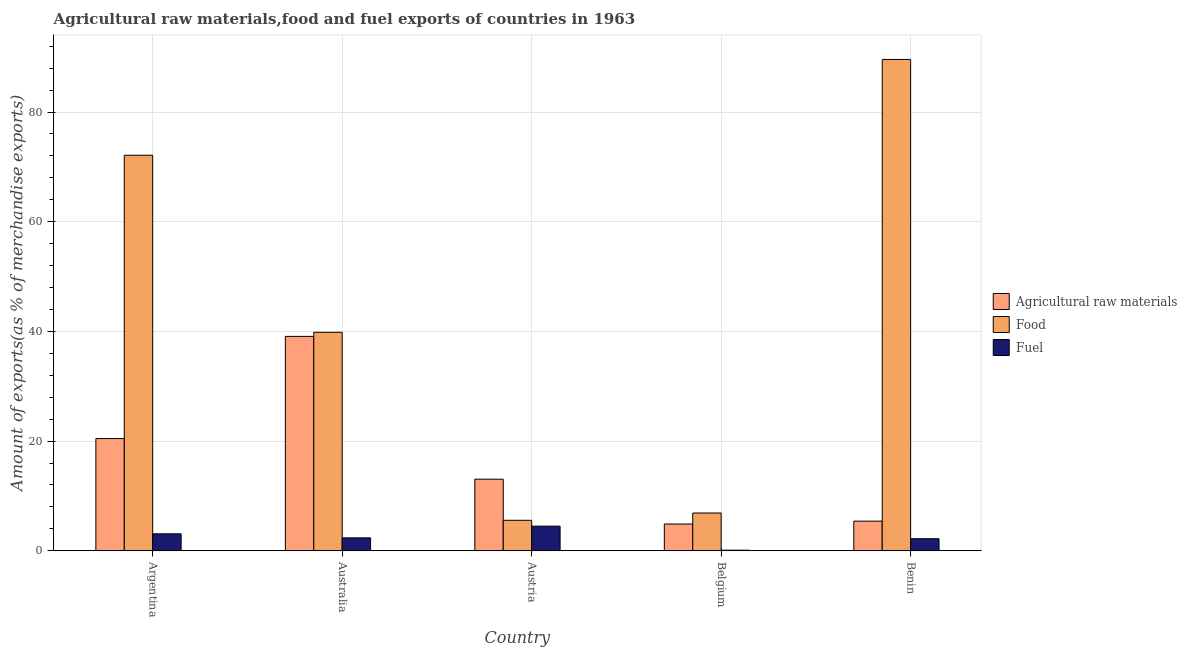How many groups of bars are there?
Your answer should be compact. 5. Are the number of bars per tick equal to the number of legend labels?
Offer a terse response. Yes. Are the number of bars on each tick of the X-axis equal?
Provide a short and direct response. Yes. What is the percentage of food exports in Australia?
Provide a succinct answer. 39.83. Across all countries, what is the maximum percentage of food exports?
Offer a very short reply. 89.59. Across all countries, what is the minimum percentage of fuel exports?
Offer a terse response. 0.11. In which country was the percentage of fuel exports maximum?
Ensure brevity in your answer.  Austria. What is the total percentage of fuel exports in the graph?
Offer a terse response. 12.24. What is the difference between the percentage of fuel exports in Argentina and that in Australia?
Give a very brief answer. 0.74. What is the difference between the percentage of raw materials exports in Benin and the percentage of fuel exports in Austria?
Your answer should be very brief. 0.91. What is the average percentage of food exports per country?
Keep it short and to the point. 42.8. What is the difference between the percentage of food exports and percentage of fuel exports in Argentina?
Make the answer very short. 69.03. In how many countries, is the percentage of fuel exports greater than 80 %?
Provide a short and direct response. 0. What is the ratio of the percentage of food exports in Australia to that in Belgium?
Your answer should be compact. 5.78. Is the percentage of food exports in Argentina less than that in Benin?
Offer a very short reply. Yes. Is the difference between the percentage of food exports in Argentina and Australia greater than the difference between the percentage of raw materials exports in Argentina and Australia?
Give a very brief answer. Yes. What is the difference between the highest and the second highest percentage of food exports?
Give a very brief answer. 17.46. What is the difference between the highest and the lowest percentage of raw materials exports?
Your answer should be very brief. 34.21. What does the 2nd bar from the left in Benin represents?
Make the answer very short. Food. What does the 3rd bar from the right in Benin represents?
Keep it short and to the point. Agricultural raw materials. How many bars are there?
Your response must be concise. 15. Does the graph contain any zero values?
Make the answer very short. No. Where does the legend appear in the graph?
Your answer should be compact. Center right. How are the legend labels stacked?
Your answer should be compact. Vertical. What is the title of the graph?
Provide a short and direct response. Agricultural raw materials,food and fuel exports of countries in 1963. What is the label or title of the Y-axis?
Keep it short and to the point. Amount of exports(as % of merchandise exports). What is the Amount of exports(as % of merchandise exports) of Agricultural raw materials in Argentina?
Your answer should be very brief. 20.46. What is the Amount of exports(as % of merchandise exports) of Food in Argentina?
Make the answer very short. 72.12. What is the Amount of exports(as % of merchandise exports) in Fuel in Argentina?
Make the answer very short. 3.09. What is the Amount of exports(as % of merchandise exports) of Agricultural raw materials in Australia?
Give a very brief answer. 39.09. What is the Amount of exports(as % of merchandise exports) of Food in Australia?
Keep it short and to the point. 39.83. What is the Amount of exports(as % of merchandise exports) of Fuel in Australia?
Make the answer very short. 2.35. What is the Amount of exports(as % of merchandise exports) of Agricultural raw materials in Austria?
Provide a short and direct response. 13.06. What is the Amount of exports(as % of merchandise exports) in Food in Austria?
Keep it short and to the point. 5.56. What is the Amount of exports(as % of merchandise exports) in Fuel in Austria?
Offer a terse response. 4.49. What is the Amount of exports(as % of merchandise exports) of Agricultural raw materials in Belgium?
Ensure brevity in your answer.  4.88. What is the Amount of exports(as % of merchandise exports) of Food in Belgium?
Provide a succinct answer. 6.89. What is the Amount of exports(as % of merchandise exports) in Fuel in Belgium?
Your answer should be very brief. 0.11. What is the Amount of exports(as % of merchandise exports) in Agricultural raw materials in Benin?
Your response must be concise. 5.4. What is the Amount of exports(as % of merchandise exports) of Food in Benin?
Give a very brief answer. 89.59. What is the Amount of exports(as % of merchandise exports) of Fuel in Benin?
Keep it short and to the point. 2.2. Across all countries, what is the maximum Amount of exports(as % of merchandise exports) of Agricultural raw materials?
Provide a succinct answer. 39.09. Across all countries, what is the maximum Amount of exports(as % of merchandise exports) of Food?
Make the answer very short. 89.59. Across all countries, what is the maximum Amount of exports(as % of merchandise exports) of Fuel?
Ensure brevity in your answer.  4.49. Across all countries, what is the minimum Amount of exports(as % of merchandise exports) in Agricultural raw materials?
Your answer should be compact. 4.88. Across all countries, what is the minimum Amount of exports(as % of merchandise exports) in Food?
Offer a very short reply. 5.56. Across all countries, what is the minimum Amount of exports(as % of merchandise exports) of Fuel?
Your answer should be compact. 0.11. What is the total Amount of exports(as % of merchandise exports) in Agricultural raw materials in the graph?
Your response must be concise. 82.88. What is the total Amount of exports(as % of merchandise exports) in Food in the graph?
Your answer should be compact. 214. What is the total Amount of exports(as % of merchandise exports) in Fuel in the graph?
Make the answer very short. 12.24. What is the difference between the Amount of exports(as % of merchandise exports) of Agricultural raw materials in Argentina and that in Australia?
Your answer should be very brief. -18.63. What is the difference between the Amount of exports(as % of merchandise exports) in Food in Argentina and that in Australia?
Offer a terse response. 32.29. What is the difference between the Amount of exports(as % of merchandise exports) of Fuel in Argentina and that in Australia?
Provide a short and direct response. 0.74. What is the difference between the Amount of exports(as % of merchandise exports) of Agricultural raw materials in Argentina and that in Austria?
Make the answer very short. 7.4. What is the difference between the Amount of exports(as % of merchandise exports) in Food in Argentina and that in Austria?
Your answer should be very brief. 66.57. What is the difference between the Amount of exports(as % of merchandise exports) of Fuel in Argentina and that in Austria?
Offer a very short reply. -1.4. What is the difference between the Amount of exports(as % of merchandise exports) in Agricultural raw materials in Argentina and that in Belgium?
Make the answer very short. 15.58. What is the difference between the Amount of exports(as % of merchandise exports) in Food in Argentina and that in Belgium?
Offer a terse response. 65.23. What is the difference between the Amount of exports(as % of merchandise exports) of Fuel in Argentina and that in Belgium?
Make the answer very short. 2.98. What is the difference between the Amount of exports(as % of merchandise exports) in Agricultural raw materials in Argentina and that in Benin?
Provide a short and direct response. 15.06. What is the difference between the Amount of exports(as % of merchandise exports) in Food in Argentina and that in Benin?
Provide a succinct answer. -17.46. What is the difference between the Amount of exports(as % of merchandise exports) of Fuel in Argentina and that in Benin?
Give a very brief answer. 0.89. What is the difference between the Amount of exports(as % of merchandise exports) in Agricultural raw materials in Australia and that in Austria?
Your answer should be very brief. 26.03. What is the difference between the Amount of exports(as % of merchandise exports) in Food in Australia and that in Austria?
Your answer should be very brief. 34.28. What is the difference between the Amount of exports(as % of merchandise exports) in Fuel in Australia and that in Austria?
Keep it short and to the point. -2.14. What is the difference between the Amount of exports(as % of merchandise exports) of Agricultural raw materials in Australia and that in Belgium?
Ensure brevity in your answer.  34.21. What is the difference between the Amount of exports(as % of merchandise exports) of Food in Australia and that in Belgium?
Ensure brevity in your answer.  32.94. What is the difference between the Amount of exports(as % of merchandise exports) of Fuel in Australia and that in Belgium?
Ensure brevity in your answer.  2.25. What is the difference between the Amount of exports(as % of merchandise exports) of Agricultural raw materials in Australia and that in Benin?
Keep it short and to the point. 33.69. What is the difference between the Amount of exports(as % of merchandise exports) of Food in Australia and that in Benin?
Provide a short and direct response. -49.75. What is the difference between the Amount of exports(as % of merchandise exports) of Fuel in Australia and that in Benin?
Your response must be concise. 0.15. What is the difference between the Amount of exports(as % of merchandise exports) in Agricultural raw materials in Austria and that in Belgium?
Give a very brief answer. 8.18. What is the difference between the Amount of exports(as % of merchandise exports) of Food in Austria and that in Belgium?
Provide a succinct answer. -1.33. What is the difference between the Amount of exports(as % of merchandise exports) in Fuel in Austria and that in Belgium?
Your answer should be very brief. 4.39. What is the difference between the Amount of exports(as % of merchandise exports) of Agricultural raw materials in Austria and that in Benin?
Your answer should be compact. 7.65. What is the difference between the Amount of exports(as % of merchandise exports) of Food in Austria and that in Benin?
Your answer should be compact. -84.03. What is the difference between the Amount of exports(as % of merchandise exports) of Fuel in Austria and that in Benin?
Your answer should be very brief. 2.29. What is the difference between the Amount of exports(as % of merchandise exports) in Agricultural raw materials in Belgium and that in Benin?
Offer a very short reply. -0.52. What is the difference between the Amount of exports(as % of merchandise exports) in Food in Belgium and that in Benin?
Your response must be concise. -82.7. What is the difference between the Amount of exports(as % of merchandise exports) in Fuel in Belgium and that in Benin?
Your answer should be compact. -2.09. What is the difference between the Amount of exports(as % of merchandise exports) in Agricultural raw materials in Argentina and the Amount of exports(as % of merchandise exports) in Food in Australia?
Provide a succinct answer. -19.38. What is the difference between the Amount of exports(as % of merchandise exports) of Agricultural raw materials in Argentina and the Amount of exports(as % of merchandise exports) of Fuel in Australia?
Offer a very short reply. 18.11. What is the difference between the Amount of exports(as % of merchandise exports) in Food in Argentina and the Amount of exports(as % of merchandise exports) in Fuel in Australia?
Your response must be concise. 69.77. What is the difference between the Amount of exports(as % of merchandise exports) of Agricultural raw materials in Argentina and the Amount of exports(as % of merchandise exports) of Food in Austria?
Keep it short and to the point. 14.9. What is the difference between the Amount of exports(as % of merchandise exports) of Agricultural raw materials in Argentina and the Amount of exports(as % of merchandise exports) of Fuel in Austria?
Make the answer very short. 15.97. What is the difference between the Amount of exports(as % of merchandise exports) of Food in Argentina and the Amount of exports(as % of merchandise exports) of Fuel in Austria?
Offer a terse response. 67.63. What is the difference between the Amount of exports(as % of merchandise exports) of Agricultural raw materials in Argentina and the Amount of exports(as % of merchandise exports) of Food in Belgium?
Offer a very short reply. 13.57. What is the difference between the Amount of exports(as % of merchandise exports) of Agricultural raw materials in Argentina and the Amount of exports(as % of merchandise exports) of Fuel in Belgium?
Offer a terse response. 20.35. What is the difference between the Amount of exports(as % of merchandise exports) of Food in Argentina and the Amount of exports(as % of merchandise exports) of Fuel in Belgium?
Make the answer very short. 72.02. What is the difference between the Amount of exports(as % of merchandise exports) of Agricultural raw materials in Argentina and the Amount of exports(as % of merchandise exports) of Food in Benin?
Keep it short and to the point. -69.13. What is the difference between the Amount of exports(as % of merchandise exports) of Agricultural raw materials in Argentina and the Amount of exports(as % of merchandise exports) of Fuel in Benin?
Provide a succinct answer. 18.26. What is the difference between the Amount of exports(as % of merchandise exports) in Food in Argentina and the Amount of exports(as % of merchandise exports) in Fuel in Benin?
Offer a very short reply. 69.92. What is the difference between the Amount of exports(as % of merchandise exports) of Agricultural raw materials in Australia and the Amount of exports(as % of merchandise exports) of Food in Austria?
Make the answer very short. 33.53. What is the difference between the Amount of exports(as % of merchandise exports) in Agricultural raw materials in Australia and the Amount of exports(as % of merchandise exports) in Fuel in Austria?
Provide a succinct answer. 34.59. What is the difference between the Amount of exports(as % of merchandise exports) of Food in Australia and the Amount of exports(as % of merchandise exports) of Fuel in Austria?
Give a very brief answer. 35.34. What is the difference between the Amount of exports(as % of merchandise exports) of Agricultural raw materials in Australia and the Amount of exports(as % of merchandise exports) of Food in Belgium?
Ensure brevity in your answer.  32.2. What is the difference between the Amount of exports(as % of merchandise exports) in Agricultural raw materials in Australia and the Amount of exports(as % of merchandise exports) in Fuel in Belgium?
Make the answer very short. 38.98. What is the difference between the Amount of exports(as % of merchandise exports) of Food in Australia and the Amount of exports(as % of merchandise exports) of Fuel in Belgium?
Make the answer very short. 39.73. What is the difference between the Amount of exports(as % of merchandise exports) of Agricultural raw materials in Australia and the Amount of exports(as % of merchandise exports) of Food in Benin?
Offer a very short reply. -50.5. What is the difference between the Amount of exports(as % of merchandise exports) of Agricultural raw materials in Australia and the Amount of exports(as % of merchandise exports) of Fuel in Benin?
Make the answer very short. 36.89. What is the difference between the Amount of exports(as % of merchandise exports) in Food in Australia and the Amount of exports(as % of merchandise exports) in Fuel in Benin?
Provide a succinct answer. 37.63. What is the difference between the Amount of exports(as % of merchandise exports) in Agricultural raw materials in Austria and the Amount of exports(as % of merchandise exports) in Food in Belgium?
Offer a terse response. 6.17. What is the difference between the Amount of exports(as % of merchandise exports) of Agricultural raw materials in Austria and the Amount of exports(as % of merchandise exports) of Fuel in Belgium?
Give a very brief answer. 12.95. What is the difference between the Amount of exports(as % of merchandise exports) in Food in Austria and the Amount of exports(as % of merchandise exports) in Fuel in Belgium?
Provide a short and direct response. 5.45. What is the difference between the Amount of exports(as % of merchandise exports) of Agricultural raw materials in Austria and the Amount of exports(as % of merchandise exports) of Food in Benin?
Your answer should be very brief. -76.53. What is the difference between the Amount of exports(as % of merchandise exports) of Agricultural raw materials in Austria and the Amount of exports(as % of merchandise exports) of Fuel in Benin?
Offer a very short reply. 10.86. What is the difference between the Amount of exports(as % of merchandise exports) in Food in Austria and the Amount of exports(as % of merchandise exports) in Fuel in Benin?
Offer a very short reply. 3.36. What is the difference between the Amount of exports(as % of merchandise exports) in Agricultural raw materials in Belgium and the Amount of exports(as % of merchandise exports) in Food in Benin?
Provide a succinct answer. -84.71. What is the difference between the Amount of exports(as % of merchandise exports) in Agricultural raw materials in Belgium and the Amount of exports(as % of merchandise exports) in Fuel in Benin?
Provide a short and direct response. 2.68. What is the difference between the Amount of exports(as % of merchandise exports) in Food in Belgium and the Amount of exports(as % of merchandise exports) in Fuel in Benin?
Provide a short and direct response. 4.69. What is the average Amount of exports(as % of merchandise exports) in Agricultural raw materials per country?
Offer a terse response. 16.58. What is the average Amount of exports(as % of merchandise exports) in Food per country?
Ensure brevity in your answer.  42.8. What is the average Amount of exports(as % of merchandise exports) of Fuel per country?
Make the answer very short. 2.45. What is the difference between the Amount of exports(as % of merchandise exports) in Agricultural raw materials and Amount of exports(as % of merchandise exports) in Food in Argentina?
Your answer should be very brief. -51.66. What is the difference between the Amount of exports(as % of merchandise exports) in Agricultural raw materials and Amount of exports(as % of merchandise exports) in Fuel in Argentina?
Your response must be concise. 17.37. What is the difference between the Amount of exports(as % of merchandise exports) in Food and Amount of exports(as % of merchandise exports) in Fuel in Argentina?
Your answer should be compact. 69.03. What is the difference between the Amount of exports(as % of merchandise exports) of Agricultural raw materials and Amount of exports(as % of merchandise exports) of Food in Australia?
Your answer should be compact. -0.75. What is the difference between the Amount of exports(as % of merchandise exports) in Agricultural raw materials and Amount of exports(as % of merchandise exports) in Fuel in Australia?
Your answer should be very brief. 36.74. What is the difference between the Amount of exports(as % of merchandise exports) in Food and Amount of exports(as % of merchandise exports) in Fuel in Australia?
Your answer should be compact. 37.48. What is the difference between the Amount of exports(as % of merchandise exports) in Agricultural raw materials and Amount of exports(as % of merchandise exports) in Food in Austria?
Provide a short and direct response. 7.5. What is the difference between the Amount of exports(as % of merchandise exports) of Agricultural raw materials and Amount of exports(as % of merchandise exports) of Fuel in Austria?
Make the answer very short. 8.56. What is the difference between the Amount of exports(as % of merchandise exports) of Food and Amount of exports(as % of merchandise exports) of Fuel in Austria?
Offer a very short reply. 1.06. What is the difference between the Amount of exports(as % of merchandise exports) in Agricultural raw materials and Amount of exports(as % of merchandise exports) in Food in Belgium?
Your response must be concise. -2.01. What is the difference between the Amount of exports(as % of merchandise exports) of Agricultural raw materials and Amount of exports(as % of merchandise exports) of Fuel in Belgium?
Your response must be concise. 4.77. What is the difference between the Amount of exports(as % of merchandise exports) of Food and Amount of exports(as % of merchandise exports) of Fuel in Belgium?
Provide a short and direct response. 6.78. What is the difference between the Amount of exports(as % of merchandise exports) of Agricultural raw materials and Amount of exports(as % of merchandise exports) of Food in Benin?
Your answer should be very brief. -84.19. What is the difference between the Amount of exports(as % of merchandise exports) in Agricultural raw materials and Amount of exports(as % of merchandise exports) in Fuel in Benin?
Keep it short and to the point. 3.2. What is the difference between the Amount of exports(as % of merchandise exports) of Food and Amount of exports(as % of merchandise exports) of Fuel in Benin?
Offer a very short reply. 87.39. What is the ratio of the Amount of exports(as % of merchandise exports) in Agricultural raw materials in Argentina to that in Australia?
Give a very brief answer. 0.52. What is the ratio of the Amount of exports(as % of merchandise exports) of Food in Argentina to that in Australia?
Provide a succinct answer. 1.81. What is the ratio of the Amount of exports(as % of merchandise exports) in Fuel in Argentina to that in Australia?
Give a very brief answer. 1.31. What is the ratio of the Amount of exports(as % of merchandise exports) in Agricultural raw materials in Argentina to that in Austria?
Make the answer very short. 1.57. What is the ratio of the Amount of exports(as % of merchandise exports) in Food in Argentina to that in Austria?
Give a very brief answer. 12.98. What is the ratio of the Amount of exports(as % of merchandise exports) of Fuel in Argentina to that in Austria?
Make the answer very short. 0.69. What is the ratio of the Amount of exports(as % of merchandise exports) in Agricultural raw materials in Argentina to that in Belgium?
Your answer should be very brief. 4.19. What is the ratio of the Amount of exports(as % of merchandise exports) of Food in Argentina to that in Belgium?
Ensure brevity in your answer.  10.47. What is the ratio of the Amount of exports(as % of merchandise exports) in Fuel in Argentina to that in Belgium?
Your answer should be very brief. 29.29. What is the ratio of the Amount of exports(as % of merchandise exports) in Agricultural raw materials in Argentina to that in Benin?
Make the answer very short. 3.79. What is the ratio of the Amount of exports(as % of merchandise exports) in Food in Argentina to that in Benin?
Your answer should be very brief. 0.81. What is the ratio of the Amount of exports(as % of merchandise exports) in Fuel in Argentina to that in Benin?
Offer a very short reply. 1.4. What is the ratio of the Amount of exports(as % of merchandise exports) in Agricultural raw materials in Australia to that in Austria?
Give a very brief answer. 2.99. What is the ratio of the Amount of exports(as % of merchandise exports) in Food in Australia to that in Austria?
Ensure brevity in your answer.  7.17. What is the ratio of the Amount of exports(as % of merchandise exports) of Fuel in Australia to that in Austria?
Ensure brevity in your answer.  0.52. What is the ratio of the Amount of exports(as % of merchandise exports) in Agricultural raw materials in Australia to that in Belgium?
Give a very brief answer. 8.01. What is the ratio of the Amount of exports(as % of merchandise exports) in Food in Australia to that in Belgium?
Your answer should be very brief. 5.78. What is the ratio of the Amount of exports(as % of merchandise exports) in Fuel in Australia to that in Belgium?
Your response must be concise. 22.29. What is the ratio of the Amount of exports(as % of merchandise exports) in Agricultural raw materials in Australia to that in Benin?
Offer a very short reply. 7.24. What is the ratio of the Amount of exports(as % of merchandise exports) in Food in Australia to that in Benin?
Offer a very short reply. 0.44. What is the ratio of the Amount of exports(as % of merchandise exports) in Fuel in Australia to that in Benin?
Ensure brevity in your answer.  1.07. What is the ratio of the Amount of exports(as % of merchandise exports) in Agricultural raw materials in Austria to that in Belgium?
Offer a terse response. 2.68. What is the ratio of the Amount of exports(as % of merchandise exports) of Food in Austria to that in Belgium?
Offer a terse response. 0.81. What is the ratio of the Amount of exports(as % of merchandise exports) of Fuel in Austria to that in Belgium?
Give a very brief answer. 42.58. What is the ratio of the Amount of exports(as % of merchandise exports) in Agricultural raw materials in Austria to that in Benin?
Offer a terse response. 2.42. What is the ratio of the Amount of exports(as % of merchandise exports) in Food in Austria to that in Benin?
Provide a short and direct response. 0.06. What is the ratio of the Amount of exports(as % of merchandise exports) in Fuel in Austria to that in Benin?
Offer a very short reply. 2.04. What is the ratio of the Amount of exports(as % of merchandise exports) of Agricultural raw materials in Belgium to that in Benin?
Your response must be concise. 0.9. What is the ratio of the Amount of exports(as % of merchandise exports) of Food in Belgium to that in Benin?
Provide a succinct answer. 0.08. What is the ratio of the Amount of exports(as % of merchandise exports) in Fuel in Belgium to that in Benin?
Your response must be concise. 0.05. What is the difference between the highest and the second highest Amount of exports(as % of merchandise exports) in Agricultural raw materials?
Keep it short and to the point. 18.63. What is the difference between the highest and the second highest Amount of exports(as % of merchandise exports) of Food?
Offer a terse response. 17.46. What is the difference between the highest and the second highest Amount of exports(as % of merchandise exports) of Fuel?
Give a very brief answer. 1.4. What is the difference between the highest and the lowest Amount of exports(as % of merchandise exports) in Agricultural raw materials?
Your answer should be compact. 34.21. What is the difference between the highest and the lowest Amount of exports(as % of merchandise exports) of Food?
Your response must be concise. 84.03. What is the difference between the highest and the lowest Amount of exports(as % of merchandise exports) in Fuel?
Offer a terse response. 4.39. 